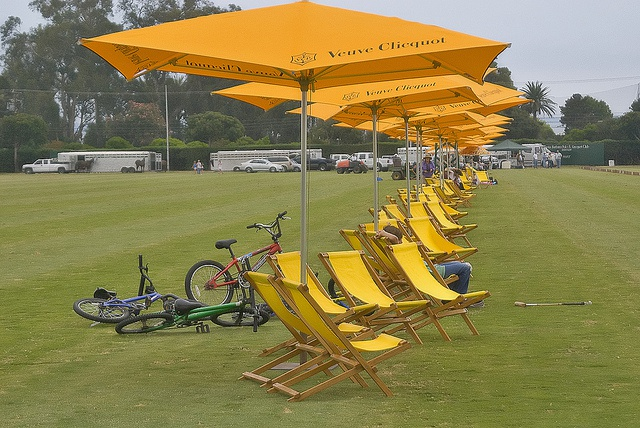Describe the objects in this image and their specific colors. I can see umbrella in lightgray and orange tones, chair in lightgray, olive, and tan tones, chair in lightgray, olive, and gold tones, chair in lightgray, olive, and gold tones, and bicycle in lightgray, black, gray, olive, and darkgreen tones in this image. 